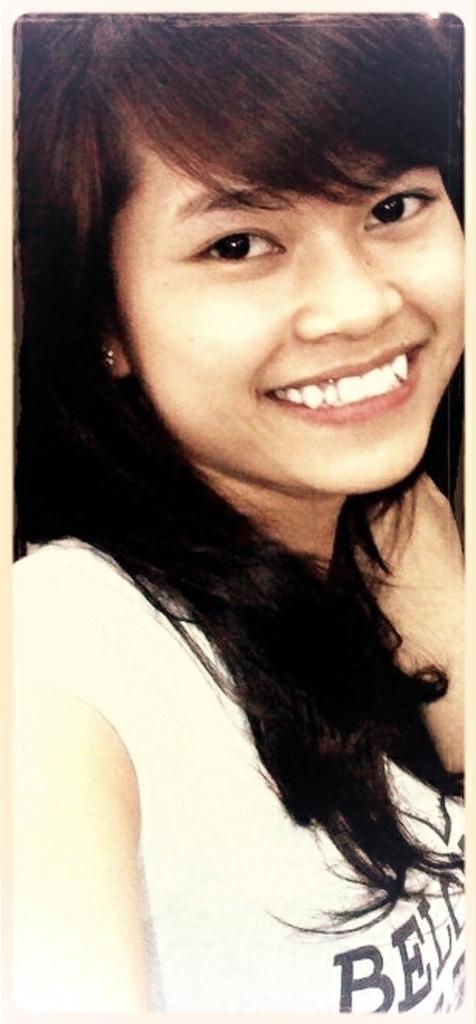Could you give a brief overview of what you see in this image? In this image we can see a woman. 